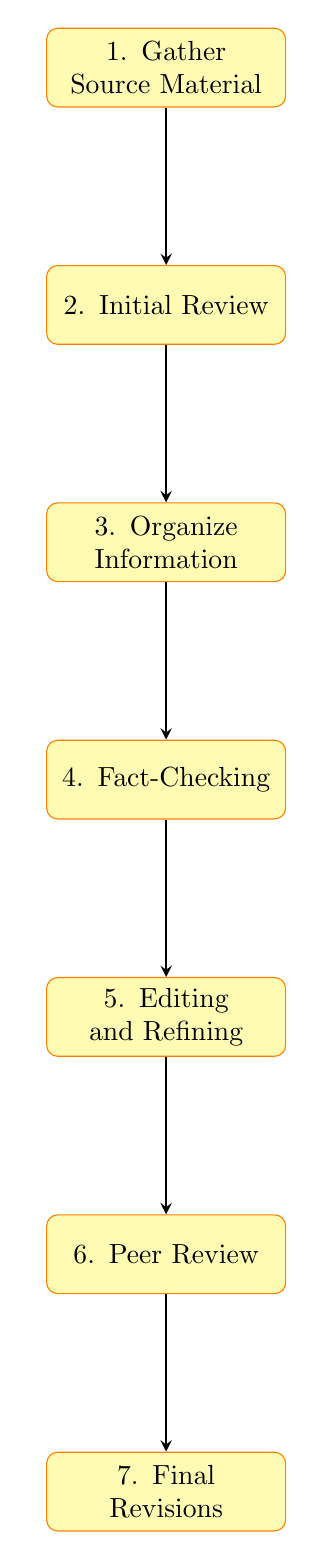What is the first step in the workflow? The first step, as indicated in the diagram, is "Gather Source Material". This can be directly identified by looking at the top node of the flow chart.
Answer: Gather Source Material How many nodes are present in the diagram? By counting the individual elements within the flow chart, there are seven distinct nodes that outline different stages of the workflow.
Answer: 7 What step follows the "Initial Review"? The diagram shows that the step that follows "Initial Review" is "Organize Information", directly indicating the flow between the two nodes.
Answer: Organize Information What is the last stage before "Final Revisions"? The last stage before "Final Revisions" is "Peer Review", which is connected to "Final Revisions" by an arrow demonstrating the sequence.
Answer: Peer Review Which step entails verifying information accuracy? The step involving the verification of information accuracy is "Fact-Checking", as illustrated in the diagram which denotes this process specifically.
Answer: Fact-Checking What is the relationship between "Editing and Refining" and "Fact-Checking"? The relationship is sequential; "Fact-Checking" directly leads into "Editing and Refining", indicating that editing occurs after the information has been verified.
Answer: Sequential How does the workflow start and end? The workflow starts at "Gather Source Material" and proceeds through the steps until it ends at "Final Revisions", creating a linear progression through the tasks.
Answer: Start: Gather Source Material, End: Final Revisions What type of feedback is incorporated during the process? The type of feedback that is incorporated comes from "Peer Review", where the edited draft is sent to colleagues or historians for input and verification.
Answer: Peer Review In which step is the content edited for clarity? The content is edited for clarity in the "Editing and Refining" step, which occurs after the fact-checking process, as depicted in the flow chart.
Answer: Editing and Refining 